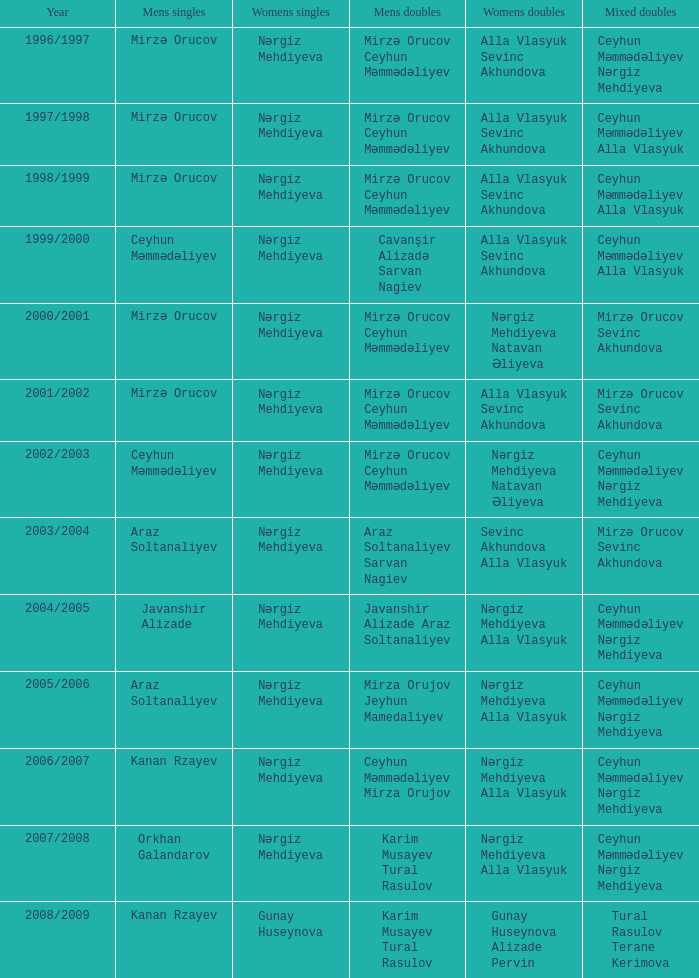Who were all womens doubles for the year 2000/2001? Nərgiz Mehdiyeva Natavan Əliyeva. 